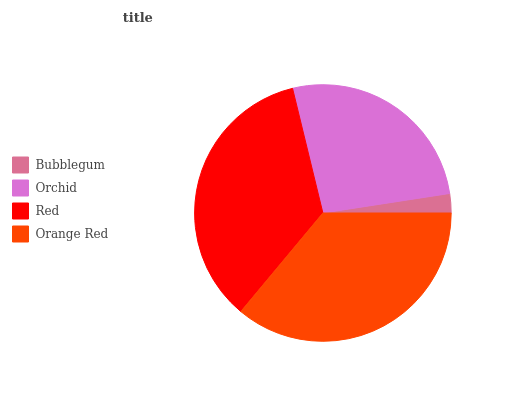Is Bubblegum the minimum?
Answer yes or no. Yes. Is Orange Red the maximum?
Answer yes or no. Yes. Is Orchid the minimum?
Answer yes or no. No. Is Orchid the maximum?
Answer yes or no. No. Is Orchid greater than Bubblegum?
Answer yes or no. Yes. Is Bubblegum less than Orchid?
Answer yes or no. Yes. Is Bubblegum greater than Orchid?
Answer yes or no. No. Is Orchid less than Bubblegum?
Answer yes or no. No. Is Red the high median?
Answer yes or no. Yes. Is Orchid the low median?
Answer yes or no. Yes. Is Bubblegum the high median?
Answer yes or no. No. Is Bubblegum the low median?
Answer yes or no. No. 